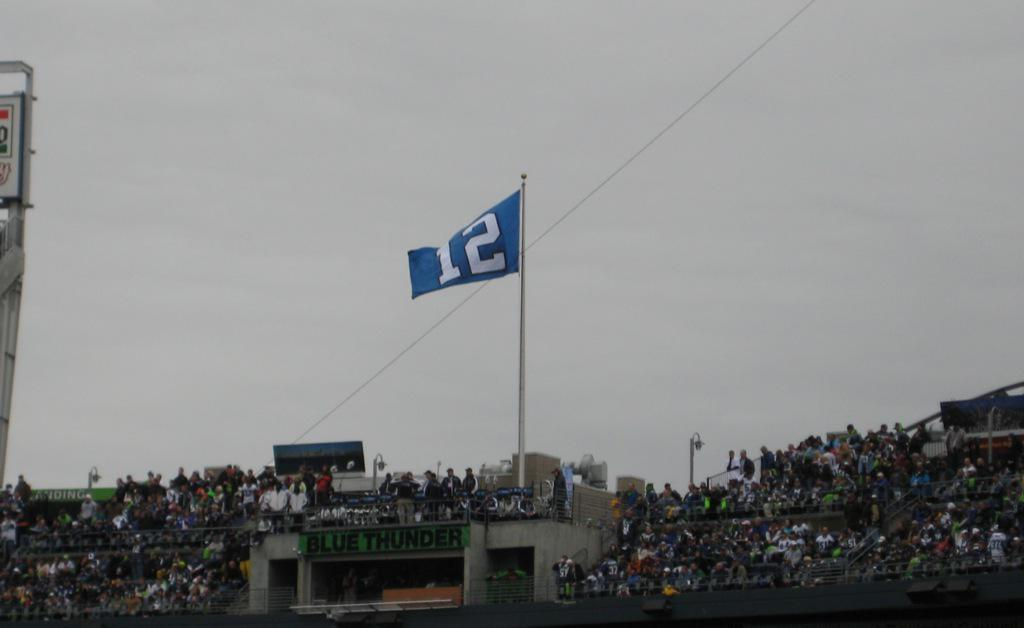<image>
Summarize the visual content of the image. A larger blue flag with a number 12 on it is on a flag pole 